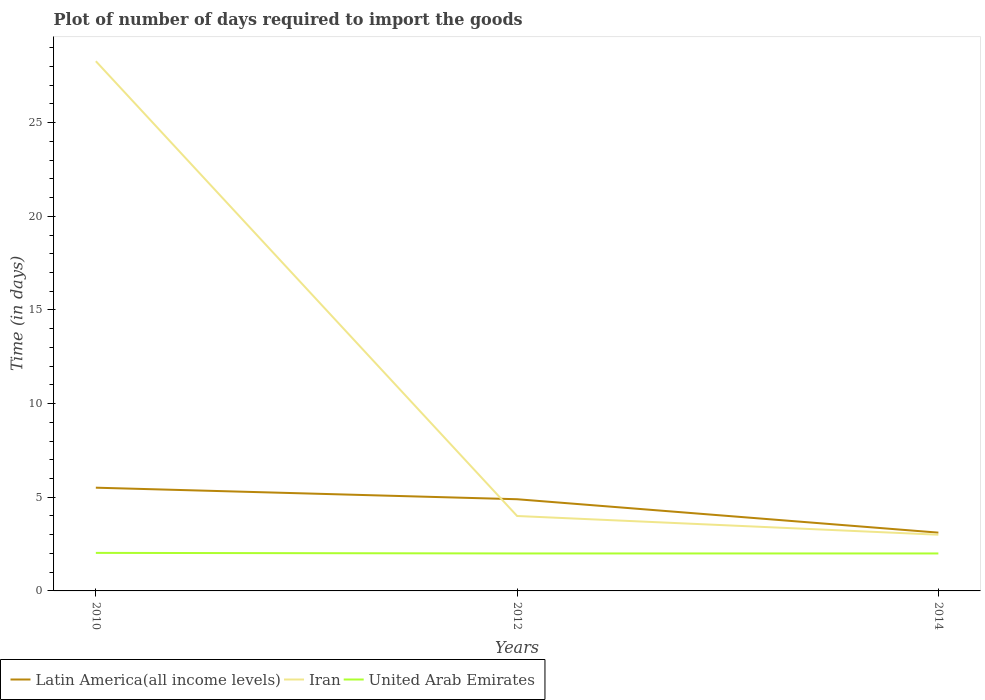Is the number of lines equal to the number of legend labels?
Provide a succinct answer. Yes. In which year was the time required to import goods in Latin America(all income levels) maximum?
Your response must be concise. 2014. What is the total time required to import goods in United Arab Emirates in the graph?
Your answer should be very brief. 0.03. What is the difference between the highest and the second highest time required to import goods in Iran?
Provide a short and direct response. 25.28. What is the difference between the highest and the lowest time required to import goods in Latin America(all income levels)?
Your response must be concise. 2. Are the values on the major ticks of Y-axis written in scientific E-notation?
Make the answer very short. No. Does the graph contain grids?
Make the answer very short. No. Where does the legend appear in the graph?
Provide a succinct answer. Bottom left. How many legend labels are there?
Your response must be concise. 3. How are the legend labels stacked?
Your answer should be very brief. Horizontal. What is the title of the graph?
Keep it short and to the point. Plot of number of days required to import the goods. What is the label or title of the Y-axis?
Give a very brief answer. Time (in days). What is the Time (in days) in Latin America(all income levels) in 2010?
Give a very brief answer. 5.51. What is the Time (in days) of Iran in 2010?
Offer a terse response. 28.28. What is the Time (in days) of United Arab Emirates in 2010?
Keep it short and to the point. 2.03. What is the Time (in days) of Latin America(all income levels) in 2012?
Make the answer very short. 4.89. What is the Time (in days) in Iran in 2012?
Your response must be concise. 4. What is the Time (in days) in United Arab Emirates in 2012?
Provide a succinct answer. 2. What is the Time (in days) of Latin America(all income levels) in 2014?
Offer a terse response. 3.11. What is the Time (in days) in Iran in 2014?
Make the answer very short. 3. What is the Time (in days) in United Arab Emirates in 2014?
Provide a short and direct response. 2. Across all years, what is the maximum Time (in days) in Latin America(all income levels)?
Give a very brief answer. 5.51. Across all years, what is the maximum Time (in days) in Iran?
Offer a very short reply. 28.28. Across all years, what is the maximum Time (in days) in United Arab Emirates?
Ensure brevity in your answer.  2.03. Across all years, what is the minimum Time (in days) of Latin America(all income levels)?
Keep it short and to the point. 3.11. Across all years, what is the minimum Time (in days) of Iran?
Offer a very short reply. 3. Across all years, what is the minimum Time (in days) of United Arab Emirates?
Provide a short and direct response. 2. What is the total Time (in days) in Latin America(all income levels) in the graph?
Provide a succinct answer. 13.52. What is the total Time (in days) in Iran in the graph?
Offer a very short reply. 35.28. What is the total Time (in days) of United Arab Emirates in the graph?
Provide a short and direct response. 6.03. What is the difference between the Time (in days) of Latin America(all income levels) in 2010 and that in 2012?
Your answer should be compact. 0.62. What is the difference between the Time (in days) in Iran in 2010 and that in 2012?
Give a very brief answer. 24.28. What is the difference between the Time (in days) of United Arab Emirates in 2010 and that in 2012?
Ensure brevity in your answer.  0.03. What is the difference between the Time (in days) of Latin America(all income levels) in 2010 and that in 2014?
Make the answer very short. 2.4. What is the difference between the Time (in days) of Iran in 2010 and that in 2014?
Offer a terse response. 25.28. What is the difference between the Time (in days) of United Arab Emirates in 2010 and that in 2014?
Offer a terse response. 0.03. What is the difference between the Time (in days) of Latin America(all income levels) in 2012 and that in 2014?
Provide a short and direct response. 1.78. What is the difference between the Time (in days) in United Arab Emirates in 2012 and that in 2014?
Give a very brief answer. 0. What is the difference between the Time (in days) in Latin America(all income levels) in 2010 and the Time (in days) in Iran in 2012?
Give a very brief answer. 1.51. What is the difference between the Time (in days) in Latin America(all income levels) in 2010 and the Time (in days) in United Arab Emirates in 2012?
Offer a terse response. 3.51. What is the difference between the Time (in days) in Iran in 2010 and the Time (in days) in United Arab Emirates in 2012?
Ensure brevity in your answer.  26.28. What is the difference between the Time (in days) in Latin America(all income levels) in 2010 and the Time (in days) in Iran in 2014?
Provide a short and direct response. 2.51. What is the difference between the Time (in days) in Latin America(all income levels) in 2010 and the Time (in days) in United Arab Emirates in 2014?
Make the answer very short. 3.51. What is the difference between the Time (in days) in Iran in 2010 and the Time (in days) in United Arab Emirates in 2014?
Your response must be concise. 26.28. What is the difference between the Time (in days) in Latin America(all income levels) in 2012 and the Time (in days) in Iran in 2014?
Your response must be concise. 1.89. What is the difference between the Time (in days) in Latin America(all income levels) in 2012 and the Time (in days) in United Arab Emirates in 2014?
Give a very brief answer. 2.89. What is the difference between the Time (in days) in Iran in 2012 and the Time (in days) in United Arab Emirates in 2014?
Give a very brief answer. 2. What is the average Time (in days) of Latin America(all income levels) per year?
Provide a succinct answer. 4.51. What is the average Time (in days) in Iran per year?
Provide a short and direct response. 11.76. What is the average Time (in days) of United Arab Emirates per year?
Your response must be concise. 2.01. In the year 2010, what is the difference between the Time (in days) in Latin America(all income levels) and Time (in days) in Iran?
Ensure brevity in your answer.  -22.77. In the year 2010, what is the difference between the Time (in days) of Latin America(all income levels) and Time (in days) of United Arab Emirates?
Offer a very short reply. 3.48. In the year 2010, what is the difference between the Time (in days) of Iran and Time (in days) of United Arab Emirates?
Give a very brief answer. 26.25. In the year 2012, what is the difference between the Time (in days) in Latin America(all income levels) and Time (in days) in Iran?
Give a very brief answer. 0.89. In the year 2012, what is the difference between the Time (in days) in Latin America(all income levels) and Time (in days) in United Arab Emirates?
Make the answer very short. 2.89. What is the ratio of the Time (in days) in Latin America(all income levels) in 2010 to that in 2012?
Provide a succinct answer. 1.13. What is the ratio of the Time (in days) in Iran in 2010 to that in 2012?
Offer a very short reply. 7.07. What is the ratio of the Time (in days) in United Arab Emirates in 2010 to that in 2012?
Provide a succinct answer. 1.01. What is the ratio of the Time (in days) of Latin America(all income levels) in 2010 to that in 2014?
Keep it short and to the point. 1.77. What is the ratio of the Time (in days) in Iran in 2010 to that in 2014?
Provide a short and direct response. 9.43. What is the ratio of the Time (in days) in Latin America(all income levels) in 2012 to that in 2014?
Keep it short and to the point. 1.57. What is the ratio of the Time (in days) of Iran in 2012 to that in 2014?
Provide a short and direct response. 1.33. What is the difference between the highest and the second highest Time (in days) of Latin America(all income levels)?
Keep it short and to the point. 0.62. What is the difference between the highest and the second highest Time (in days) of Iran?
Offer a terse response. 24.28. What is the difference between the highest and the lowest Time (in days) of Latin America(all income levels)?
Keep it short and to the point. 2.4. What is the difference between the highest and the lowest Time (in days) in Iran?
Offer a very short reply. 25.28. 